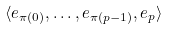Convert formula to latex. <formula><loc_0><loc_0><loc_500><loc_500>\langle e _ { \pi ( 0 ) } , \dots , e _ { \pi ( p - 1 ) } , e _ { p } \rangle</formula> 